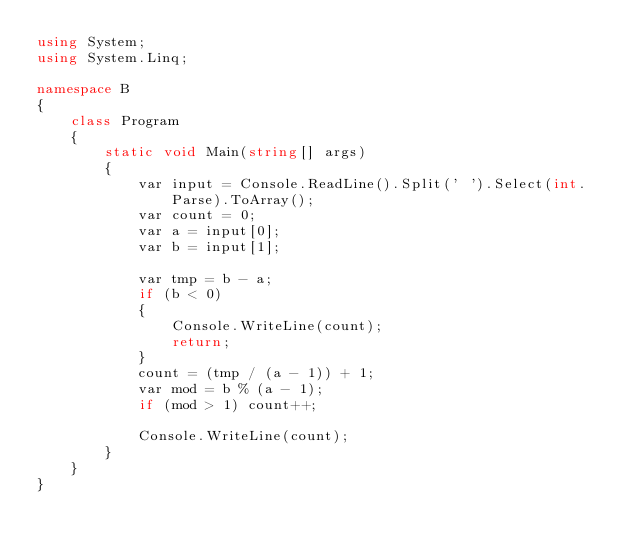<code> <loc_0><loc_0><loc_500><loc_500><_C#_>using System;
using System.Linq;

namespace B
{
    class Program
    {
        static void Main(string[] args)
        {
            var input = Console.ReadLine().Split(' ').Select(int.Parse).ToArray();
            var count = 0;
            var a = input[0];
            var b = input[1];

            var tmp = b - a;
            if (b < 0)
            {
                Console.WriteLine(count);
                return;
            }
            count = (tmp / (a - 1)) + 1;
            var mod = b % (a - 1);
            if (mod > 1) count++;

            Console.WriteLine(count);
        }
    }
}
</code> 